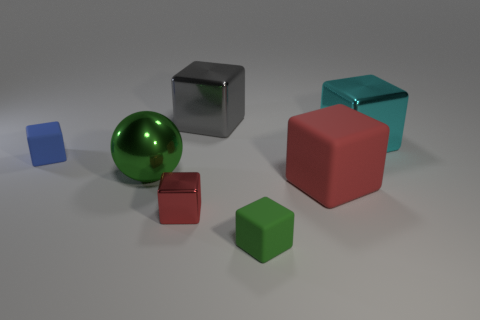Are there more big green objects in front of the small red thing than small green rubber cubes that are behind the large red rubber thing?
Offer a terse response. No. The green cube is what size?
Offer a very short reply. Small. There is a green thing to the left of the red metallic block; what shape is it?
Your response must be concise. Sphere. Do the blue rubber object and the green shiny object have the same shape?
Make the answer very short. No. Are there an equal number of large metal balls that are right of the gray metal object and red matte balls?
Offer a terse response. Yes. The tiny red metal thing has what shape?
Keep it short and to the point. Cube. Is there any other thing that has the same color as the sphere?
Make the answer very short. Yes. Does the block behind the cyan metallic thing have the same size as the green thing behind the tiny red block?
Keep it short and to the point. Yes. There is a red object behind the metallic cube that is in front of the shiny ball; what is its shape?
Provide a short and direct response. Cube. Do the blue rubber thing and the block that is behind the cyan metallic block have the same size?
Give a very brief answer. No. 